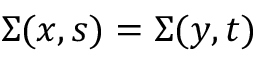<formula> <loc_0><loc_0><loc_500><loc_500>\Sigma ( x , s ) = \Sigma ( y , t )</formula> 